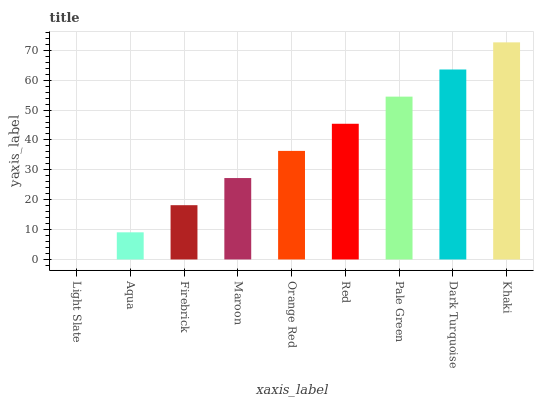Is Light Slate the minimum?
Answer yes or no. Yes. Is Khaki the maximum?
Answer yes or no. Yes. Is Aqua the minimum?
Answer yes or no. No. Is Aqua the maximum?
Answer yes or no. No. Is Aqua greater than Light Slate?
Answer yes or no. Yes. Is Light Slate less than Aqua?
Answer yes or no. Yes. Is Light Slate greater than Aqua?
Answer yes or no. No. Is Aqua less than Light Slate?
Answer yes or no. No. Is Orange Red the high median?
Answer yes or no. Yes. Is Orange Red the low median?
Answer yes or no. Yes. Is Pale Green the high median?
Answer yes or no. No. Is Dark Turquoise the low median?
Answer yes or no. No. 